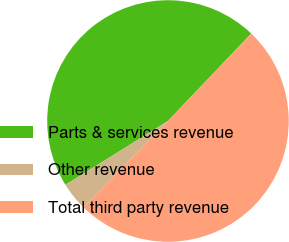<chart> <loc_0><loc_0><loc_500><loc_500><pie_chart><fcel>Parts & services revenue<fcel>Other revenue<fcel>Total third party revenue<nl><fcel>45.98%<fcel>3.83%<fcel>50.19%<nl></chart> 